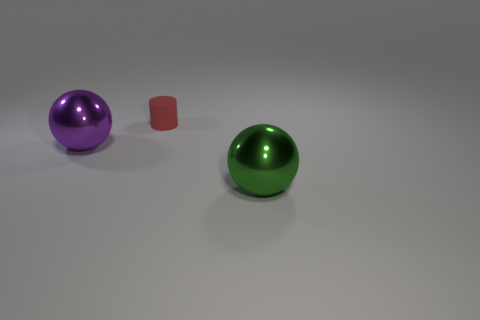What is the material of the large thing in front of the sphere that is behind the green thing?
Provide a short and direct response. Metal. What size is the thing behind the purple ball?
Keep it short and to the point. Small. The object that is behind the green sphere and to the right of the purple metal ball is what color?
Make the answer very short. Red. There is a object that is in front of the purple thing; does it have the same size as the large purple metal sphere?
Provide a succinct answer. Yes. There is a shiny ball to the left of the red matte object; is there a tiny red matte thing that is in front of it?
Ensure brevity in your answer.  No. What is the material of the green sphere?
Give a very brief answer. Metal. Are there any large green shiny spheres in front of the small red cylinder?
Keep it short and to the point. Yes. What size is the other thing that is the same shape as the purple object?
Your answer should be compact. Large. Is the number of small things that are right of the red matte cylinder the same as the number of large spheres that are to the right of the big green metallic object?
Offer a terse response. Yes. How many large metal balls are there?
Your answer should be very brief. 2. 